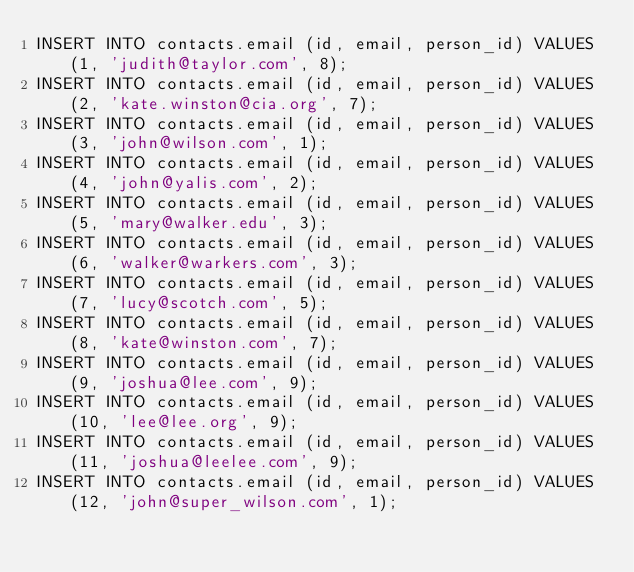Convert code to text. <code><loc_0><loc_0><loc_500><loc_500><_SQL_>INSERT INTO contacts.email (id, email, person_id) VALUES (1, 'judith@taylor.com', 8);
INSERT INTO contacts.email (id, email, person_id) VALUES (2, 'kate.winston@cia.org', 7);
INSERT INTO contacts.email (id, email, person_id) VALUES (3, 'john@wilson.com', 1);
INSERT INTO contacts.email (id, email, person_id) VALUES (4, 'john@yalis.com', 2);
INSERT INTO contacts.email (id, email, person_id) VALUES (5, 'mary@walker.edu', 3);
INSERT INTO contacts.email (id, email, person_id) VALUES (6, 'walker@warkers.com', 3);
INSERT INTO contacts.email (id, email, person_id) VALUES (7, 'lucy@scotch.com', 5);
INSERT INTO contacts.email (id, email, person_id) VALUES (8, 'kate@winston.com', 7);
INSERT INTO contacts.email (id, email, person_id) VALUES (9, 'joshua@lee.com', 9);
INSERT INTO contacts.email (id, email, person_id) VALUES (10, 'lee@lee.org', 9);
INSERT INTO contacts.email (id, email, person_id) VALUES (11, 'joshua@leelee.com', 9);
INSERT INTO contacts.email (id, email, person_id) VALUES (12, 'john@super_wilson.com', 1);
</code> 